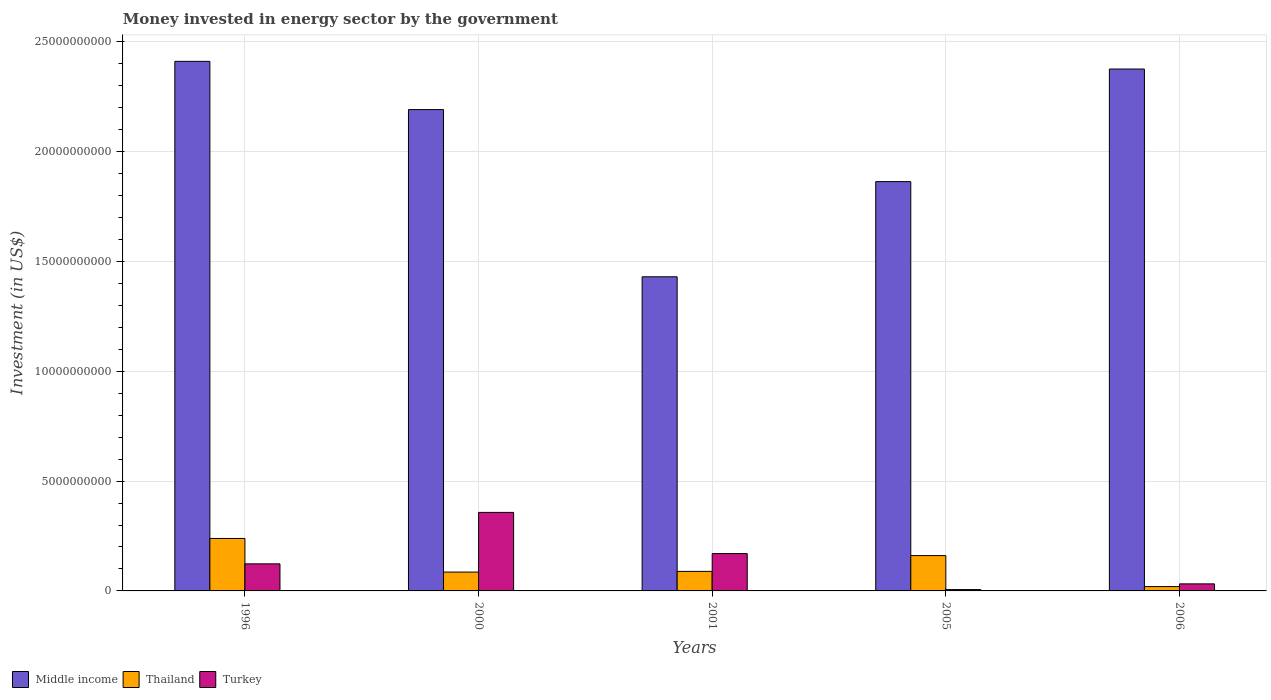Are the number of bars per tick equal to the number of legend labels?
Keep it short and to the point. Yes. How many bars are there on the 4th tick from the left?
Keep it short and to the point. 3. How many bars are there on the 4th tick from the right?
Your answer should be very brief. 3. What is the money spent in energy sector in Turkey in 2006?
Give a very brief answer. 3.21e+08. Across all years, what is the maximum money spent in energy sector in Middle income?
Keep it short and to the point. 2.41e+1. Across all years, what is the minimum money spent in energy sector in Thailand?
Ensure brevity in your answer.  1.97e+08. In which year was the money spent in energy sector in Thailand maximum?
Your answer should be very brief. 1996. In which year was the money spent in energy sector in Middle income minimum?
Keep it short and to the point. 2001. What is the total money spent in energy sector in Middle income in the graph?
Provide a short and direct response. 1.03e+11. What is the difference between the money spent in energy sector in Thailand in 1996 and that in 2000?
Your answer should be very brief. 1.53e+09. What is the difference between the money spent in energy sector in Middle income in 2000 and the money spent in energy sector in Thailand in 2005?
Your answer should be compact. 2.03e+1. What is the average money spent in energy sector in Middle income per year?
Your response must be concise. 2.05e+1. In the year 2000, what is the difference between the money spent in energy sector in Middle income and money spent in energy sector in Turkey?
Give a very brief answer. 1.83e+1. What is the ratio of the money spent in energy sector in Thailand in 2000 to that in 2006?
Make the answer very short. 4.35. Is the difference between the money spent in energy sector in Middle income in 1996 and 2006 greater than the difference between the money spent in energy sector in Turkey in 1996 and 2006?
Offer a very short reply. No. What is the difference between the highest and the second highest money spent in energy sector in Thailand?
Give a very brief answer. 7.80e+08. What is the difference between the highest and the lowest money spent in energy sector in Middle income?
Keep it short and to the point. 9.81e+09. In how many years, is the money spent in energy sector in Thailand greater than the average money spent in energy sector in Thailand taken over all years?
Provide a short and direct response. 2. What does the 1st bar from the left in 2005 represents?
Ensure brevity in your answer.  Middle income. What does the 2nd bar from the right in 1996 represents?
Your response must be concise. Thailand. Is it the case that in every year, the sum of the money spent in energy sector in Turkey and money spent in energy sector in Middle income is greater than the money spent in energy sector in Thailand?
Keep it short and to the point. Yes. How many years are there in the graph?
Your response must be concise. 5. What is the difference between two consecutive major ticks on the Y-axis?
Provide a short and direct response. 5.00e+09. Are the values on the major ticks of Y-axis written in scientific E-notation?
Offer a very short reply. No. Does the graph contain any zero values?
Your answer should be compact. No. Where does the legend appear in the graph?
Your answer should be very brief. Bottom left. How are the legend labels stacked?
Provide a succinct answer. Horizontal. What is the title of the graph?
Provide a short and direct response. Money invested in energy sector by the government. Does "Latvia" appear as one of the legend labels in the graph?
Give a very brief answer. No. What is the label or title of the Y-axis?
Make the answer very short. Investment (in US$). What is the Investment (in US$) of Middle income in 1996?
Offer a very short reply. 2.41e+1. What is the Investment (in US$) of Thailand in 1996?
Provide a short and direct response. 2.39e+09. What is the Investment (in US$) of Turkey in 1996?
Offer a very short reply. 1.23e+09. What is the Investment (in US$) in Middle income in 2000?
Your answer should be very brief. 2.19e+1. What is the Investment (in US$) of Thailand in 2000?
Give a very brief answer. 8.58e+08. What is the Investment (in US$) in Turkey in 2000?
Offer a terse response. 3.58e+09. What is the Investment (in US$) of Middle income in 2001?
Provide a short and direct response. 1.43e+1. What is the Investment (in US$) of Thailand in 2001?
Give a very brief answer. 8.90e+08. What is the Investment (in US$) of Turkey in 2001?
Your response must be concise. 1.70e+09. What is the Investment (in US$) of Middle income in 2005?
Keep it short and to the point. 1.86e+1. What is the Investment (in US$) of Thailand in 2005?
Your answer should be compact. 1.61e+09. What is the Investment (in US$) in Turkey in 2005?
Offer a very short reply. 6.08e+07. What is the Investment (in US$) in Middle income in 2006?
Keep it short and to the point. 2.38e+1. What is the Investment (in US$) of Thailand in 2006?
Offer a terse response. 1.97e+08. What is the Investment (in US$) of Turkey in 2006?
Provide a short and direct response. 3.21e+08. Across all years, what is the maximum Investment (in US$) of Middle income?
Offer a terse response. 2.41e+1. Across all years, what is the maximum Investment (in US$) of Thailand?
Offer a terse response. 2.39e+09. Across all years, what is the maximum Investment (in US$) in Turkey?
Offer a very short reply. 3.58e+09. Across all years, what is the minimum Investment (in US$) of Middle income?
Your response must be concise. 1.43e+1. Across all years, what is the minimum Investment (in US$) of Thailand?
Offer a terse response. 1.97e+08. Across all years, what is the minimum Investment (in US$) of Turkey?
Give a very brief answer. 6.08e+07. What is the total Investment (in US$) in Middle income in the graph?
Give a very brief answer. 1.03e+11. What is the total Investment (in US$) in Thailand in the graph?
Provide a succinct answer. 5.94e+09. What is the total Investment (in US$) in Turkey in the graph?
Ensure brevity in your answer.  6.89e+09. What is the difference between the Investment (in US$) in Middle income in 1996 and that in 2000?
Ensure brevity in your answer.  2.20e+09. What is the difference between the Investment (in US$) in Thailand in 1996 and that in 2000?
Provide a succinct answer. 1.53e+09. What is the difference between the Investment (in US$) of Turkey in 1996 and that in 2000?
Keep it short and to the point. -2.34e+09. What is the difference between the Investment (in US$) in Middle income in 1996 and that in 2001?
Provide a succinct answer. 9.81e+09. What is the difference between the Investment (in US$) in Thailand in 1996 and that in 2001?
Your answer should be compact. 1.50e+09. What is the difference between the Investment (in US$) in Turkey in 1996 and that in 2001?
Ensure brevity in your answer.  -4.68e+08. What is the difference between the Investment (in US$) in Middle income in 1996 and that in 2005?
Offer a terse response. 5.48e+09. What is the difference between the Investment (in US$) of Thailand in 1996 and that in 2005?
Give a very brief answer. 7.80e+08. What is the difference between the Investment (in US$) of Turkey in 1996 and that in 2005?
Keep it short and to the point. 1.17e+09. What is the difference between the Investment (in US$) in Middle income in 1996 and that in 2006?
Keep it short and to the point. 3.50e+08. What is the difference between the Investment (in US$) in Thailand in 1996 and that in 2006?
Keep it short and to the point. 2.19e+09. What is the difference between the Investment (in US$) in Turkey in 1996 and that in 2006?
Your answer should be very brief. 9.11e+08. What is the difference between the Investment (in US$) in Middle income in 2000 and that in 2001?
Your answer should be very brief. 7.61e+09. What is the difference between the Investment (in US$) in Thailand in 2000 and that in 2001?
Make the answer very short. -3.13e+07. What is the difference between the Investment (in US$) in Turkey in 2000 and that in 2001?
Ensure brevity in your answer.  1.88e+09. What is the difference between the Investment (in US$) of Middle income in 2000 and that in 2005?
Offer a very short reply. 3.28e+09. What is the difference between the Investment (in US$) in Thailand in 2000 and that in 2005?
Ensure brevity in your answer.  -7.50e+08. What is the difference between the Investment (in US$) in Turkey in 2000 and that in 2005?
Your answer should be compact. 3.51e+09. What is the difference between the Investment (in US$) in Middle income in 2000 and that in 2006?
Your response must be concise. -1.85e+09. What is the difference between the Investment (in US$) of Thailand in 2000 and that in 2006?
Offer a terse response. 6.61e+08. What is the difference between the Investment (in US$) in Turkey in 2000 and that in 2006?
Provide a succinct answer. 3.25e+09. What is the difference between the Investment (in US$) of Middle income in 2001 and that in 2005?
Ensure brevity in your answer.  -4.33e+09. What is the difference between the Investment (in US$) of Thailand in 2001 and that in 2005?
Provide a succinct answer. -7.19e+08. What is the difference between the Investment (in US$) in Turkey in 2001 and that in 2005?
Give a very brief answer. 1.64e+09. What is the difference between the Investment (in US$) of Middle income in 2001 and that in 2006?
Offer a very short reply. -9.46e+09. What is the difference between the Investment (in US$) in Thailand in 2001 and that in 2006?
Your answer should be compact. 6.92e+08. What is the difference between the Investment (in US$) of Turkey in 2001 and that in 2006?
Offer a very short reply. 1.38e+09. What is the difference between the Investment (in US$) in Middle income in 2005 and that in 2006?
Offer a terse response. -5.13e+09. What is the difference between the Investment (in US$) in Thailand in 2005 and that in 2006?
Offer a very short reply. 1.41e+09. What is the difference between the Investment (in US$) in Turkey in 2005 and that in 2006?
Your answer should be very brief. -2.60e+08. What is the difference between the Investment (in US$) of Middle income in 1996 and the Investment (in US$) of Thailand in 2000?
Ensure brevity in your answer.  2.33e+1. What is the difference between the Investment (in US$) of Middle income in 1996 and the Investment (in US$) of Turkey in 2000?
Your answer should be very brief. 2.05e+1. What is the difference between the Investment (in US$) of Thailand in 1996 and the Investment (in US$) of Turkey in 2000?
Your answer should be compact. -1.19e+09. What is the difference between the Investment (in US$) in Middle income in 1996 and the Investment (in US$) in Thailand in 2001?
Offer a terse response. 2.32e+1. What is the difference between the Investment (in US$) in Middle income in 1996 and the Investment (in US$) in Turkey in 2001?
Make the answer very short. 2.24e+1. What is the difference between the Investment (in US$) of Thailand in 1996 and the Investment (in US$) of Turkey in 2001?
Give a very brief answer. 6.89e+08. What is the difference between the Investment (in US$) in Middle income in 1996 and the Investment (in US$) in Thailand in 2005?
Make the answer very short. 2.25e+1. What is the difference between the Investment (in US$) in Middle income in 1996 and the Investment (in US$) in Turkey in 2005?
Offer a very short reply. 2.41e+1. What is the difference between the Investment (in US$) of Thailand in 1996 and the Investment (in US$) of Turkey in 2005?
Your response must be concise. 2.33e+09. What is the difference between the Investment (in US$) of Middle income in 1996 and the Investment (in US$) of Thailand in 2006?
Provide a succinct answer. 2.39e+1. What is the difference between the Investment (in US$) in Middle income in 1996 and the Investment (in US$) in Turkey in 2006?
Your answer should be compact. 2.38e+1. What is the difference between the Investment (in US$) of Thailand in 1996 and the Investment (in US$) of Turkey in 2006?
Your answer should be compact. 2.07e+09. What is the difference between the Investment (in US$) in Middle income in 2000 and the Investment (in US$) in Thailand in 2001?
Your response must be concise. 2.10e+1. What is the difference between the Investment (in US$) of Middle income in 2000 and the Investment (in US$) of Turkey in 2001?
Your response must be concise. 2.02e+1. What is the difference between the Investment (in US$) of Thailand in 2000 and the Investment (in US$) of Turkey in 2001?
Ensure brevity in your answer.  -8.42e+08. What is the difference between the Investment (in US$) of Middle income in 2000 and the Investment (in US$) of Thailand in 2005?
Your answer should be very brief. 2.03e+1. What is the difference between the Investment (in US$) in Middle income in 2000 and the Investment (in US$) in Turkey in 2005?
Provide a succinct answer. 2.19e+1. What is the difference between the Investment (in US$) in Thailand in 2000 and the Investment (in US$) in Turkey in 2005?
Make the answer very short. 7.98e+08. What is the difference between the Investment (in US$) in Middle income in 2000 and the Investment (in US$) in Thailand in 2006?
Make the answer very short. 2.17e+1. What is the difference between the Investment (in US$) in Middle income in 2000 and the Investment (in US$) in Turkey in 2006?
Your response must be concise. 2.16e+1. What is the difference between the Investment (in US$) of Thailand in 2000 and the Investment (in US$) of Turkey in 2006?
Your answer should be very brief. 5.37e+08. What is the difference between the Investment (in US$) in Middle income in 2001 and the Investment (in US$) in Thailand in 2005?
Ensure brevity in your answer.  1.27e+1. What is the difference between the Investment (in US$) of Middle income in 2001 and the Investment (in US$) of Turkey in 2005?
Make the answer very short. 1.42e+1. What is the difference between the Investment (in US$) in Thailand in 2001 and the Investment (in US$) in Turkey in 2005?
Provide a succinct answer. 8.29e+08. What is the difference between the Investment (in US$) in Middle income in 2001 and the Investment (in US$) in Thailand in 2006?
Your answer should be compact. 1.41e+1. What is the difference between the Investment (in US$) of Middle income in 2001 and the Investment (in US$) of Turkey in 2006?
Give a very brief answer. 1.40e+1. What is the difference between the Investment (in US$) of Thailand in 2001 and the Investment (in US$) of Turkey in 2006?
Your response must be concise. 5.69e+08. What is the difference between the Investment (in US$) of Middle income in 2005 and the Investment (in US$) of Thailand in 2006?
Provide a succinct answer. 1.84e+1. What is the difference between the Investment (in US$) in Middle income in 2005 and the Investment (in US$) in Turkey in 2006?
Keep it short and to the point. 1.83e+1. What is the difference between the Investment (in US$) in Thailand in 2005 and the Investment (in US$) in Turkey in 2006?
Offer a terse response. 1.29e+09. What is the average Investment (in US$) of Middle income per year?
Give a very brief answer. 2.05e+1. What is the average Investment (in US$) in Thailand per year?
Ensure brevity in your answer.  1.19e+09. What is the average Investment (in US$) in Turkey per year?
Ensure brevity in your answer.  1.38e+09. In the year 1996, what is the difference between the Investment (in US$) in Middle income and Investment (in US$) in Thailand?
Offer a very short reply. 2.17e+1. In the year 1996, what is the difference between the Investment (in US$) of Middle income and Investment (in US$) of Turkey?
Your response must be concise. 2.29e+1. In the year 1996, what is the difference between the Investment (in US$) of Thailand and Investment (in US$) of Turkey?
Give a very brief answer. 1.16e+09. In the year 2000, what is the difference between the Investment (in US$) in Middle income and Investment (in US$) in Thailand?
Give a very brief answer. 2.11e+1. In the year 2000, what is the difference between the Investment (in US$) of Middle income and Investment (in US$) of Turkey?
Offer a terse response. 1.83e+1. In the year 2000, what is the difference between the Investment (in US$) of Thailand and Investment (in US$) of Turkey?
Offer a terse response. -2.72e+09. In the year 2001, what is the difference between the Investment (in US$) in Middle income and Investment (in US$) in Thailand?
Offer a very short reply. 1.34e+1. In the year 2001, what is the difference between the Investment (in US$) in Middle income and Investment (in US$) in Turkey?
Your answer should be compact. 1.26e+1. In the year 2001, what is the difference between the Investment (in US$) in Thailand and Investment (in US$) in Turkey?
Your answer should be very brief. -8.10e+08. In the year 2005, what is the difference between the Investment (in US$) of Middle income and Investment (in US$) of Thailand?
Offer a terse response. 1.70e+1. In the year 2005, what is the difference between the Investment (in US$) in Middle income and Investment (in US$) in Turkey?
Give a very brief answer. 1.86e+1. In the year 2005, what is the difference between the Investment (in US$) of Thailand and Investment (in US$) of Turkey?
Your answer should be very brief. 1.55e+09. In the year 2006, what is the difference between the Investment (in US$) in Middle income and Investment (in US$) in Thailand?
Make the answer very short. 2.36e+1. In the year 2006, what is the difference between the Investment (in US$) of Middle income and Investment (in US$) of Turkey?
Ensure brevity in your answer.  2.34e+1. In the year 2006, what is the difference between the Investment (in US$) in Thailand and Investment (in US$) in Turkey?
Keep it short and to the point. -1.24e+08. What is the ratio of the Investment (in US$) of Middle income in 1996 to that in 2000?
Your answer should be compact. 1.1. What is the ratio of the Investment (in US$) in Thailand in 1996 to that in 2000?
Provide a short and direct response. 2.78. What is the ratio of the Investment (in US$) of Turkey in 1996 to that in 2000?
Offer a terse response. 0.34. What is the ratio of the Investment (in US$) in Middle income in 1996 to that in 2001?
Offer a terse response. 1.69. What is the ratio of the Investment (in US$) in Thailand in 1996 to that in 2001?
Provide a short and direct response. 2.68. What is the ratio of the Investment (in US$) in Turkey in 1996 to that in 2001?
Ensure brevity in your answer.  0.72. What is the ratio of the Investment (in US$) of Middle income in 1996 to that in 2005?
Make the answer very short. 1.29. What is the ratio of the Investment (in US$) of Thailand in 1996 to that in 2005?
Provide a succinct answer. 1.48. What is the ratio of the Investment (in US$) of Turkey in 1996 to that in 2005?
Keep it short and to the point. 20.27. What is the ratio of the Investment (in US$) of Middle income in 1996 to that in 2006?
Provide a short and direct response. 1.01. What is the ratio of the Investment (in US$) in Thailand in 1996 to that in 2006?
Ensure brevity in your answer.  12.11. What is the ratio of the Investment (in US$) of Turkey in 1996 to that in 2006?
Your answer should be compact. 3.84. What is the ratio of the Investment (in US$) in Middle income in 2000 to that in 2001?
Keep it short and to the point. 1.53. What is the ratio of the Investment (in US$) of Thailand in 2000 to that in 2001?
Give a very brief answer. 0.96. What is the ratio of the Investment (in US$) of Turkey in 2000 to that in 2001?
Your answer should be very brief. 2.1. What is the ratio of the Investment (in US$) in Middle income in 2000 to that in 2005?
Your answer should be very brief. 1.18. What is the ratio of the Investment (in US$) of Thailand in 2000 to that in 2005?
Keep it short and to the point. 0.53. What is the ratio of the Investment (in US$) of Turkey in 2000 to that in 2005?
Make the answer very short. 58.8. What is the ratio of the Investment (in US$) in Middle income in 2000 to that in 2006?
Provide a short and direct response. 0.92. What is the ratio of the Investment (in US$) in Thailand in 2000 to that in 2006?
Offer a very short reply. 4.35. What is the ratio of the Investment (in US$) in Turkey in 2000 to that in 2006?
Offer a terse response. 11.14. What is the ratio of the Investment (in US$) in Middle income in 2001 to that in 2005?
Make the answer very short. 0.77. What is the ratio of the Investment (in US$) in Thailand in 2001 to that in 2005?
Your answer should be compact. 0.55. What is the ratio of the Investment (in US$) of Turkey in 2001 to that in 2005?
Give a very brief answer. 27.96. What is the ratio of the Investment (in US$) of Middle income in 2001 to that in 2006?
Provide a short and direct response. 0.6. What is the ratio of the Investment (in US$) of Thailand in 2001 to that in 2006?
Give a very brief answer. 4.51. What is the ratio of the Investment (in US$) in Turkey in 2001 to that in 2006?
Keep it short and to the point. 5.3. What is the ratio of the Investment (in US$) of Middle income in 2005 to that in 2006?
Give a very brief answer. 0.78. What is the ratio of the Investment (in US$) in Thailand in 2005 to that in 2006?
Give a very brief answer. 8.16. What is the ratio of the Investment (in US$) in Turkey in 2005 to that in 2006?
Give a very brief answer. 0.19. What is the difference between the highest and the second highest Investment (in US$) of Middle income?
Your answer should be very brief. 3.50e+08. What is the difference between the highest and the second highest Investment (in US$) of Thailand?
Ensure brevity in your answer.  7.80e+08. What is the difference between the highest and the second highest Investment (in US$) in Turkey?
Provide a succinct answer. 1.88e+09. What is the difference between the highest and the lowest Investment (in US$) in Middle income?
Offer a terse response. 9.81e+09. What is the difference between the highest and the lowest Investment (in US$) in Thailand?
Ensure brevity in your answer.  2.19e+09. What is the difference between the highest and the lowest Investment (in US$) in Turkey?
Ensure brevity in your answer.  3.51e+09. 